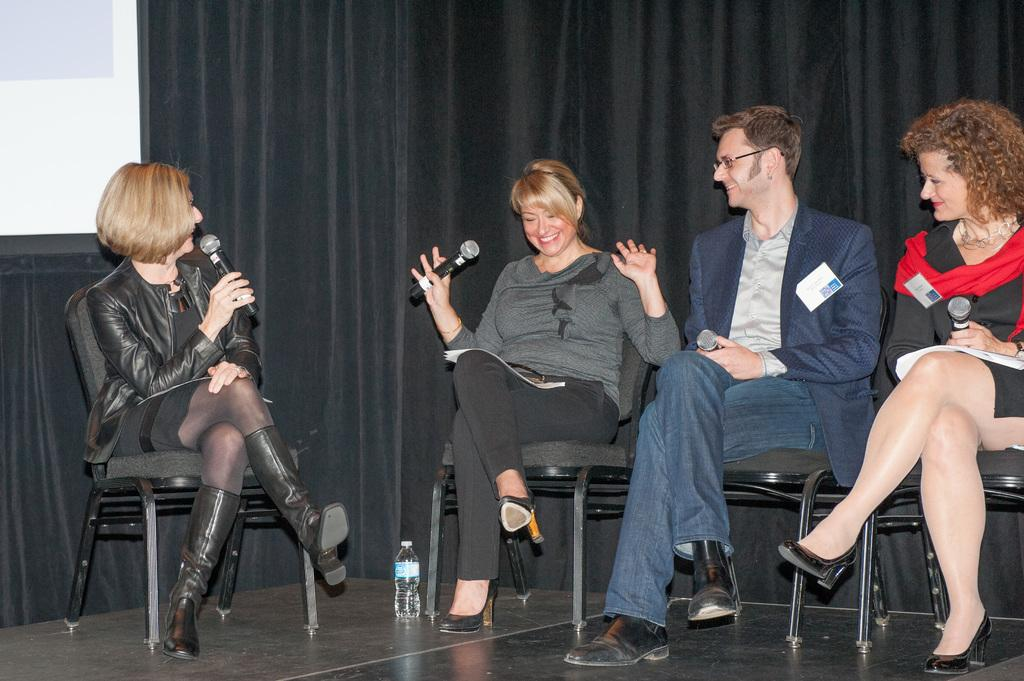How many people are in the image? There is in the image. What are the people in the image doing? The man and women are sitting on chairs and holding microphones in their hands. What is the facial expression of the people in the image? The man and women are smiling. What other objects can be seen in the image? There is a bottle and a screen in the image. What is visible in the background of the image? There are curtains in the background of the image. How many quarters are visible on the screen in the image? There are no quarters visible on the screen in the image. What time is displayed on the clock in the image? There is no clock present in the image. 